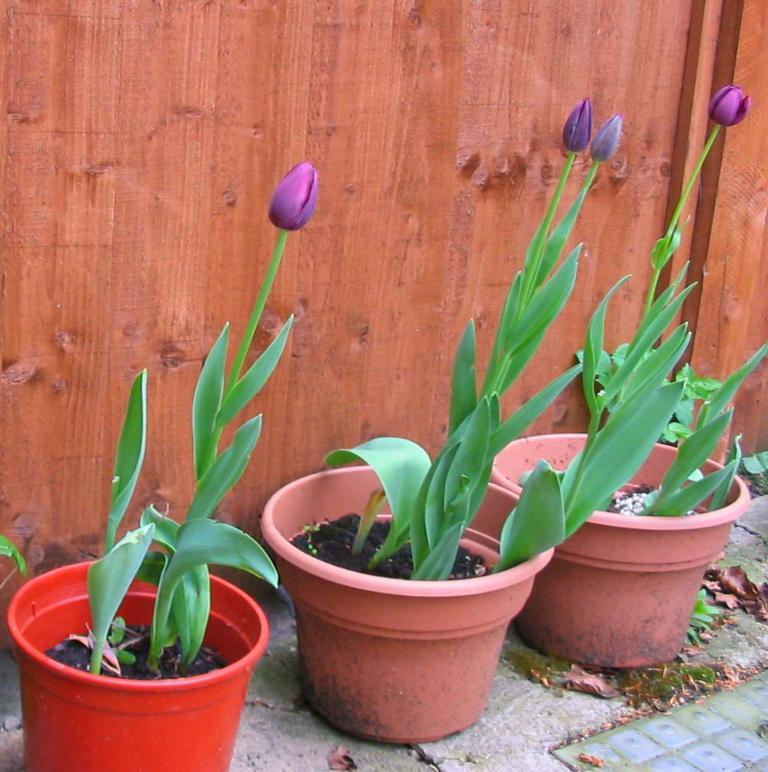What type of objects can be seen in the image? There are flower pots in the image. What stage of growth are the flowers in the image? Bud flowers are visible in the image. What material is used to construct the wall in the image? There is a wooden wall in the image. What type of surface is present in the image? There is a solid surface in the image. What type of sweater is the child wearing in the image? There are no children or sweaters present in the image. How many caps can be seen on the wooden wall in the image? There are no caps visible on the wooden wall in the image. 